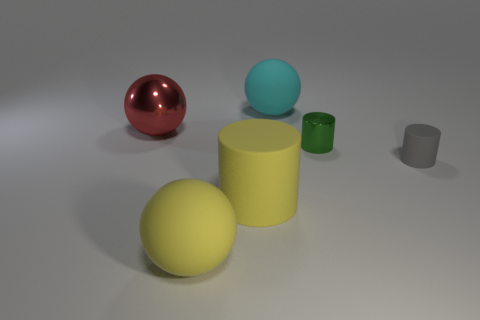Is the number of gray cylinders that are behind the red object greater than the number of small green things behind the green object?
Offer a very short reply. No. There is a object that is the same color as the large cylinder; what is its material?
Provide a succinct answer. Rubber. Is there anything else that is the same shape as the gray thing?
Give a very brief answer. Yes. What material is the object that is both on the left side of the large rubber cylinder and in front of the tiny gray cylinder?
Your answer should be very brief. Rubber. Is the big yellow cylinder made of the same material as the big sphere in front of the tiny gray object?
Make the answer very short. Yes. Is there any other thing that has the same size as the cyan matte object?
Your response must be concise. Yes. How many objects are either big metal objects or matte things in front of the tiny green metallic cylinder?
Offer a very short reply. 4. Does the shiny thing that is in front of the large metal ball have the same size as the matte cylinder to the left of the cyan matte ball?
Your answer should be compact. No. How many other objects are the same color as the tiny shiny thing?
Your response must be concise. 0. Does the gray rubber cylinder have the same size as the rubber ball to the left of the big cyan rubber object?
Keep it short and to the point. No. 